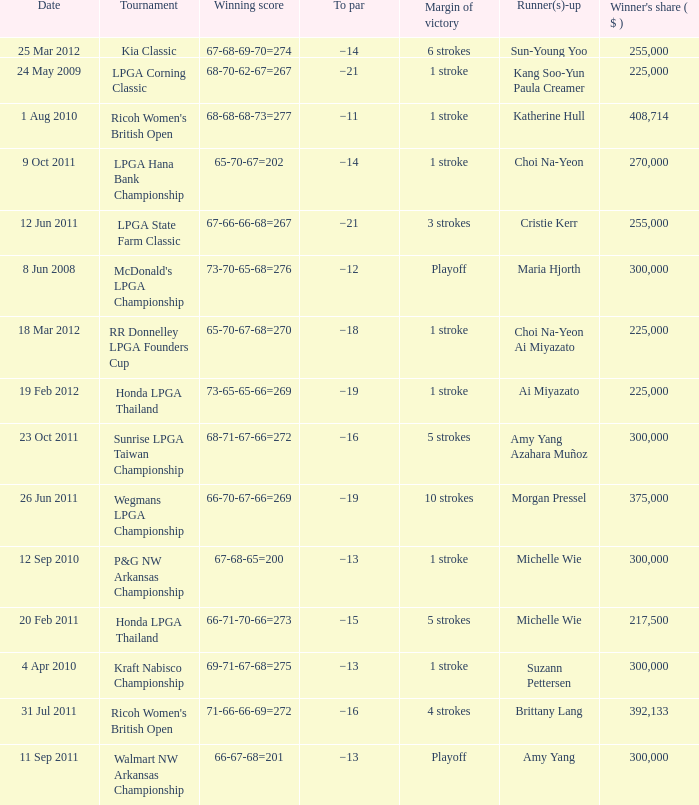Who was the runner-up in the RR Donnelley LPGA Founders Cup? Choi Na-Yeon Ai Miyazato. 